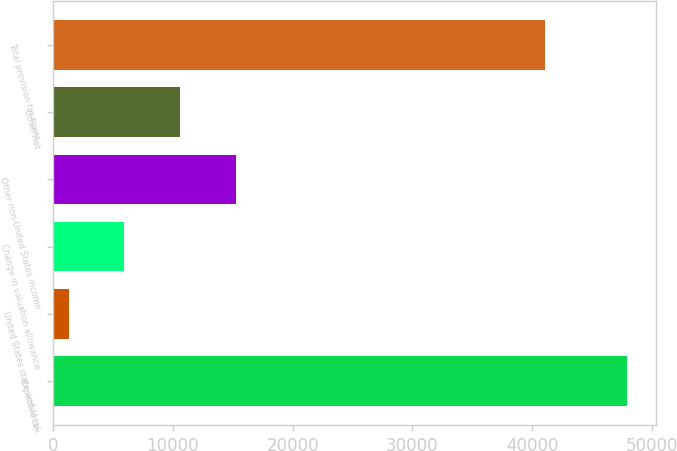Convert chart. <chart><loc_0><loc_0><loc_500><loc_500><bar_chart><fcel>Expected tax<fcel>United States state and local<fcel>Change in valuation allowance<fcel>Other non-United States income<fcel>Other net<fcel>Total provision for taxes<nl><fcel>47919<fcel>1285<fcel>5948.4<fcel>15275.2<fcel>10611.8<fcel>41073<nl></chart> 